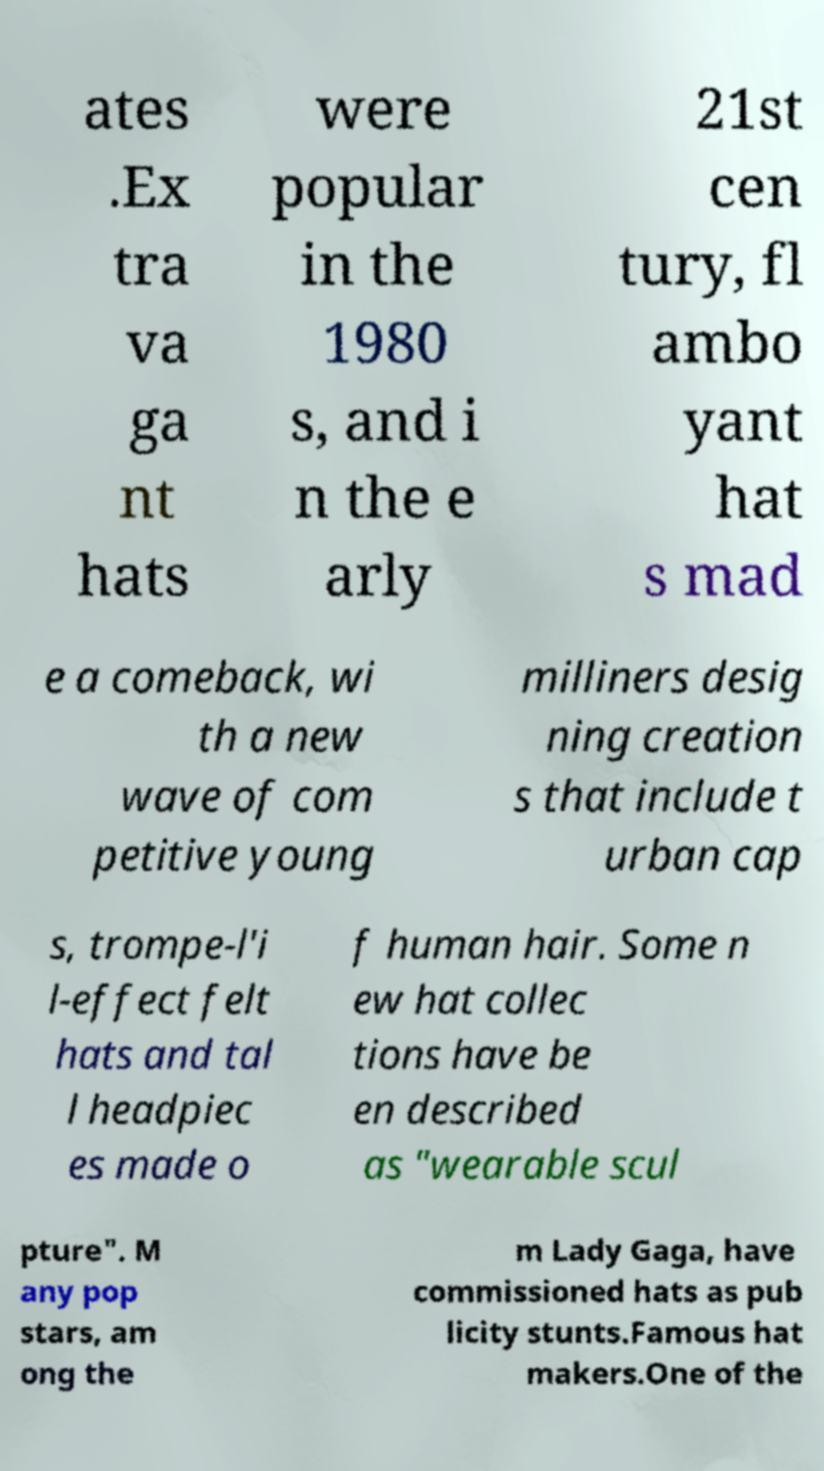Please read and relay the text visible in this image. What does it say? ates .Ex tra va ga nt hats were popular in the 1980 s, and i n the e arly 21st cen tury, fl ambo yant hat s mad e a comeback, wi th a new wave of com petitive young milliners desig ning creation s that include t urban cap s, trompe-l'i l-effect felt hats and tal l headpiec es made o f human hair. Some n ew hat collec tions have be en described as "wearable scul pture". M any pop stars, am ong the m Lady Gaga, have commissioned hats as pub licity stunts.Famous hat makers.One of the 